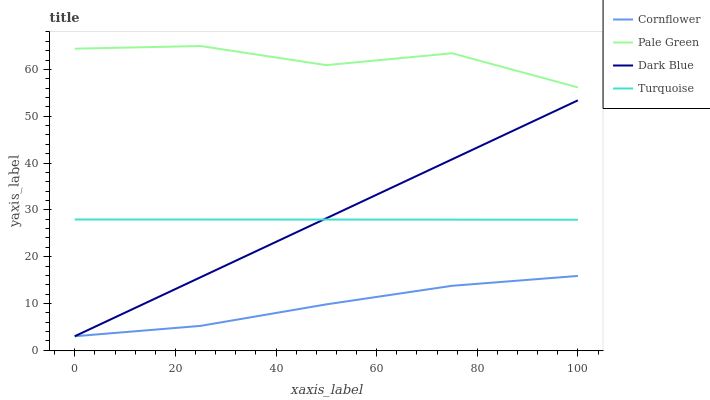Does Cornflower have the minimum area under the curve?
Answer yes or no. Yes. Does Pale Green have the maximum area under the curve?
Answer yes or no. Yes. Does Turquoise have the minimum area under the curve?
Answer yes or no. No. Does Turquoise have the maximum area under the curve?
Answer yes or no. No. Is Dark Blue the smoothest?
Answer yes or no. Yes. Is Pale Green the roughest?
Answer yes or no. Yes. Is Turquoise the smoothest?
Answer yes or no. No. Is Turquoise the roughest?
Answer yes or no. No. Does Cornflower have the lowest value?
Answer yes or no. Yes. Does Turquoise have the lowest value?
Answer yes or no. No. Does Pale Green have the highest value?
Answer yes or no. Yes. Does Turquoise have the highest value?
Answer yes or no. No. Is Cornflower less than Pale Green?
Answer yes or no. Yes. Is Pale Green greater than Cornflower?
Answer yes or no. Yes. Does Dark Blue intersect Turquoise?
Answer yes or no. Yes. Is Dark Blue less than Turquoise?
Answer yes or no. No. Is Dark Blue greater than Turquoise?
Answer yes or no. No. Does Cornflower intersect Pale Green?
Answer yes or no. No. 